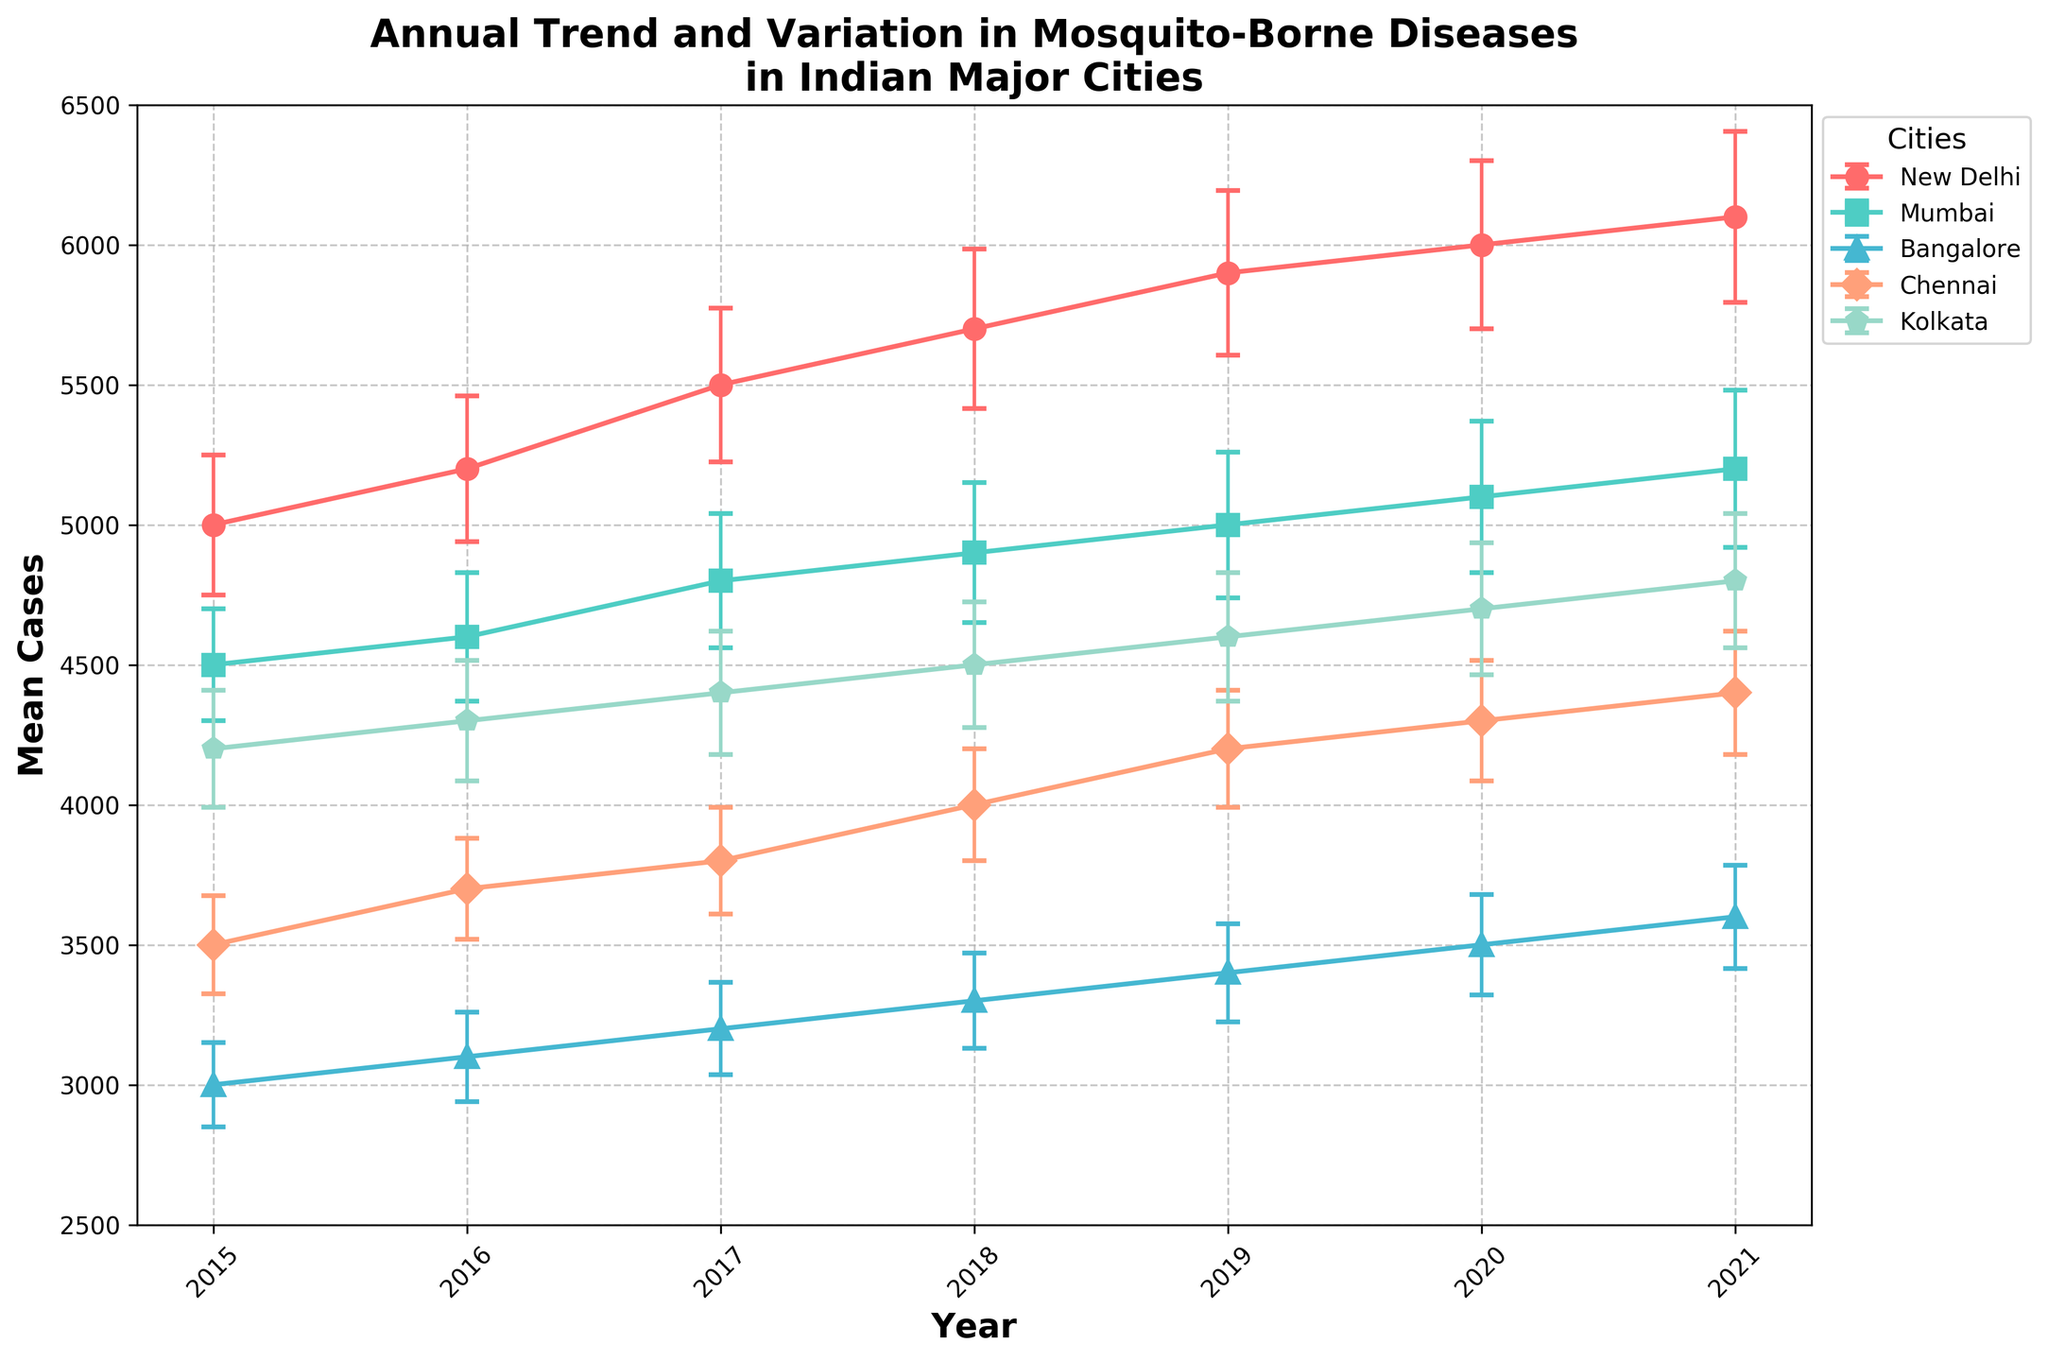What is the title of the plot? The title is written at the top of the plot in bold text. It provides an overview of what the plot depicts.
Answer: Annual Trend and Variation in Mosquito-Borne Diseases in Indian Major Cities Which city had the highest mean number of cases in 2021? To answer this, look at the error bars for 2021 and identify the topmost point for each city. Compare these mean values.
Answer: New Delhi What is the average number of mosquito-borne diseases cases in New Delhi from 2015 to 2021? Sum up the mean cases for New Delhi over the years and divide by the total number of years (7). (5000 + 5200 + 5500 + 5700 + 5900 + 6000 + 6100) / 7 = 49400 / 7
Answer: 7057 Which city had the least variation in mosquito-borne disease cases in 2020? Variation is shown by the length of the error bars. Identify the shortest error bar for the year 2020.
Answer: Bangalore How did the number of cases in Mumbai change from 2015 to 2021? Subtract the mean number of cases in 2015 from the mean number of cases in 2021 for Mumbai. 5200 - 4500 = 700
Answer: Increased by 700 Which year saw the highest number of cases in Chennai? Find the highest point for Chennai across the plot, which corresponds to the highest mean cases per year.
Answer: 2021 Is there a trend in the number of cases in Kolkata from 2015 to 2021? Observe the line for Kolkata to determine if it is generally increasing, decreasing, or neither. The line rises each year, indicating an increasing trend.
Answer: Increasing trend Which city shows the most consistent (least variable) number of cases across all years? The consistency is indicated by the shortest error bars on average across the years. Compare the lengths of error bars across the plot for all cities.
Answer: Mumbai What is the difference in mean cases between the city with the highest and the city with the lowest number of cases in 2018? Identify the maximum and minimum mean cases in 2018, then subtract the smaller number from the larger one. 5700 (New Delhi) - 3300 (Bangalore) = 2400
Answer: 2400 Which city has the largest increase in mean cases from 2015 to 2021? Calculate the difference in mean cases for each city between 2021 and 2015 and compare the values. (New Delhi: 6100-5000 = 1100), (Mumbai: 5200-4500 = 700), (Bangalore: 3600-3000 = 600), (Chennai: 4400-3500 = 900), (Kolkata: 4800-4200 = 600). New Delhi has the largest increase.
Answer: New Delhi 